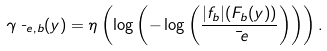Convert formula to latex. <formula><loc_0><loc_0><loc_500><loc_500>\gamma _ { \bar { \ e } , b } ( y ) = \eta \left ( \log \left ( - \log \left ( \frac { | f _ { b } | ( F _ { b } ( y ) ) } { \bar { \ e } } \right ) \right ) \right ) .</formula> 